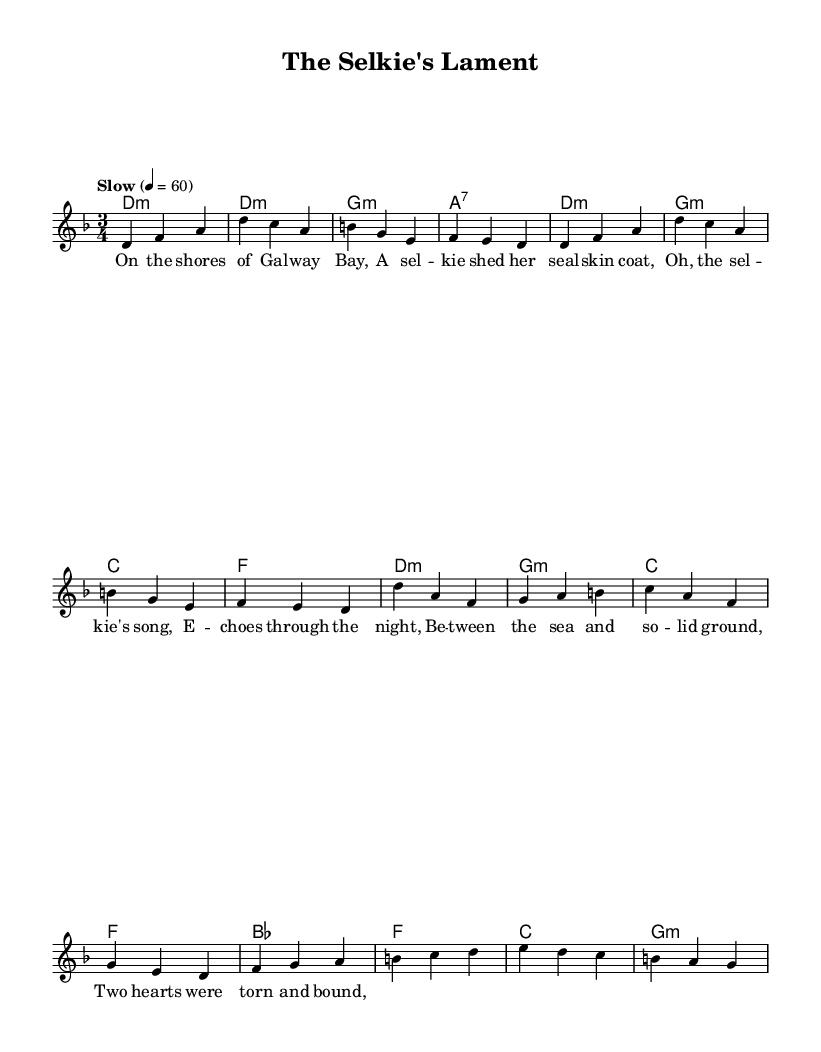What is the key signature of this music? The key signature is indicated at the beginning of the score, shown by the symbols on the staff. Here, it shows D minor, which has one flat (B flat).
Answer: D minor What is the time signature of this music? The time signature is located at the beginning of the score and shows the number of beats in each measure. Here, the time signature is 3/4, meaning there are three beats per measure.
Answer: 3/4 What tempo marking is indicated for this piece? The tempo marking is noted at the start of the score, indicating the speed at which the piece should be played. The score mentions "Slow" followed by a tempo of 60 beats per minute.
Answer: Slow How many lines are in the main melody? The main melody is represented by the staff which has five lines, a standard feature for grand staff notation.
Answer: Five lines What is the harmonic structure used in the chorus? To find the harmonic structure, we analyze the chord symbols written above the melody in the chorus section. The chords in the chorus are D minor, G minor, C major, and F major.
Answer: D minor, G minor, C major, F major What poetic theme is explored in the lyrics of this ballad? Upon analyzing the lyrics provided, they focus on themes of loss and longing, particularly relating to a selkie's lament and the between realms of sea and land.
Answer: Loss and longing What mythical creature is featured in this ballad? The lyrics specifically mention a selkie, which is a creature from Irish folklore that can transform from seal to human.
Answer: Selkie 